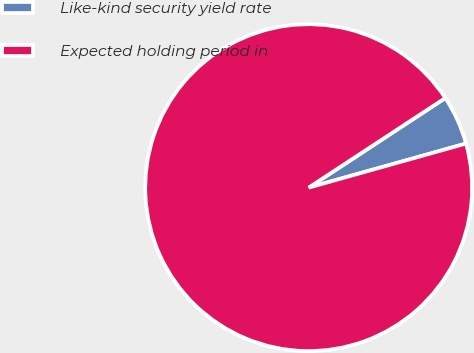<chart> <loc_0><loc_0><loc_500><loc_500><pie_chart><fcel>Like-kind security yield rate<fcel>Expected holding period in<nl><fcel>4.89%<fcel>95.11%<nl></chart> 